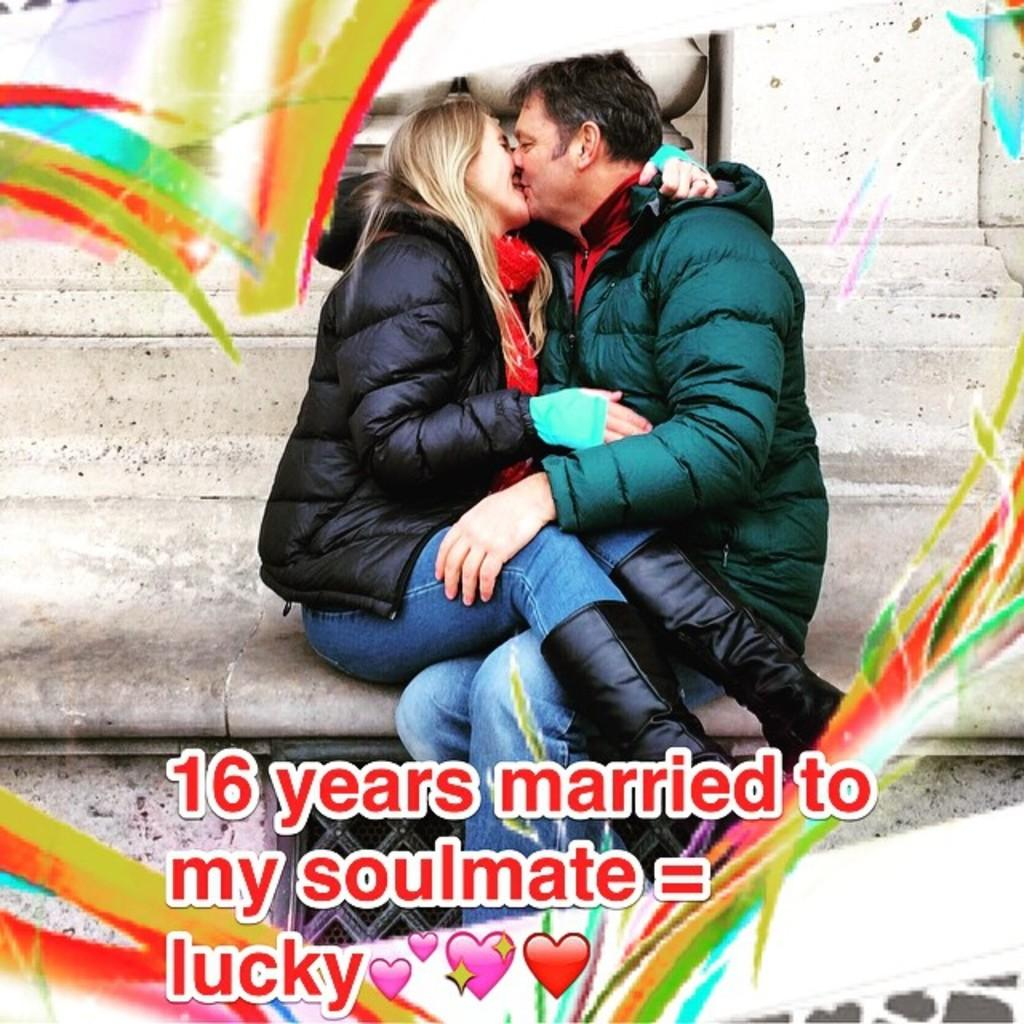What are the two people in the image doing? The woman and the man are kissing each other in the image. What type of clothing are they wearing? The woman and the man are wearing jackets. Is there any text or writing on the image? Yes, there is something written on the image. Can you see any snails crawling on the wire in the image? There is no wire or snails present in the image. 